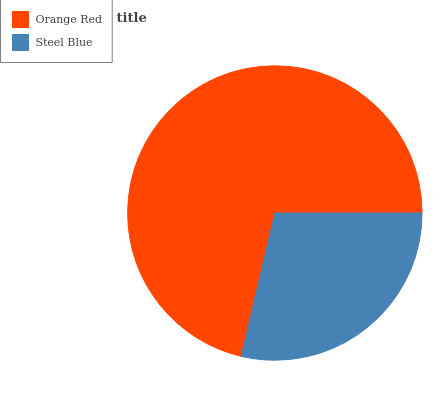Is Steel Blue the minimum?
Answer yes or no. Yes. Is Orange Red the maximum?
Answer yes or no. Yes. Is Steel Blue the maximum?
Answer yes or no. No. Is Orange Red greater than Steel Blue?
Answer yes or no. Yes. Is Steel Blue less than Orange Red?
Answer yes or no. Yes. Is Steel Blue greater than Orange Red?
Answer yes or no. No. Is Orange Red less than Steel Blue?
Answer yes or no. No. Is Orange Red the high median?
Answer yes or no. Yes. Is Steel Blue the low median?
Answer yes or no. Yes. Is Steel Blue the high median?
Answer yes or no. No. Is Orange Red the low median?
Answer yes or no. No. 